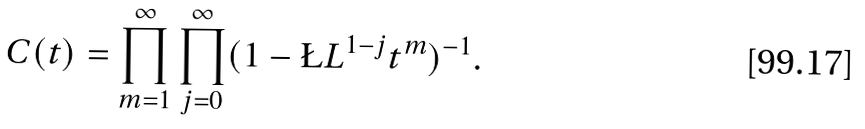Convert formula to latex. <formula><loc_0><loc_0><loc_500><loc_500>C ( t ) = \prod _ { m = 1 } ^ { \infty } \prod _ { j = 0 } ^ { \infty } ( 1 - \L L ^ { 1 - j } t ^ { m } ) ^ { - 1 } .</formula> 